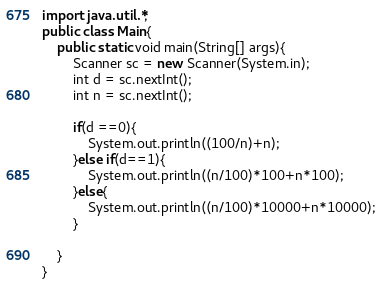<code> <loc_0><loc_0><loc_500><loc_500><_Java_>import java.util.*;
public class Main{
    public static void main(String[] args){
        Scanner sc = new Scanner(System.in);
        int d = sc.nextInt();
        int n = sc.nextInt();

        if(d ==0){
            System.out.println((100/n)+n);
        }else if(d==1){
            System.out.println((n/100)*100+n*100);
        }else{
            System.out.println((n/100)*10000+n*10000);
        }
        
    }
}
</code> 